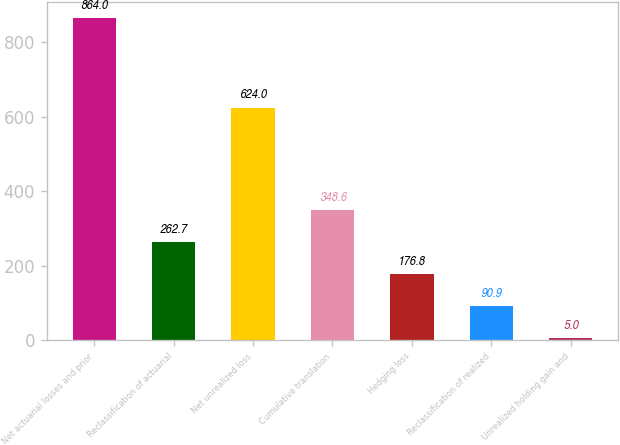<chart> <loc_0><loc_0><loc_500><loc_500><bar_chart><fcel>Net actuarial losses and prior<fcel>Reclassification of actuarial<fcel>Net unrealized loss<fcel>Cumulative translation<fcel>Hedging loss<fcel>Reclassification of realized<fcel>Unrealized holding gain and<nl><fcel>864<fcel>262.7<fcel>624<fcel>348.6<fcel>176.8<fcel>90.9<fcel>5<nl></chart> 